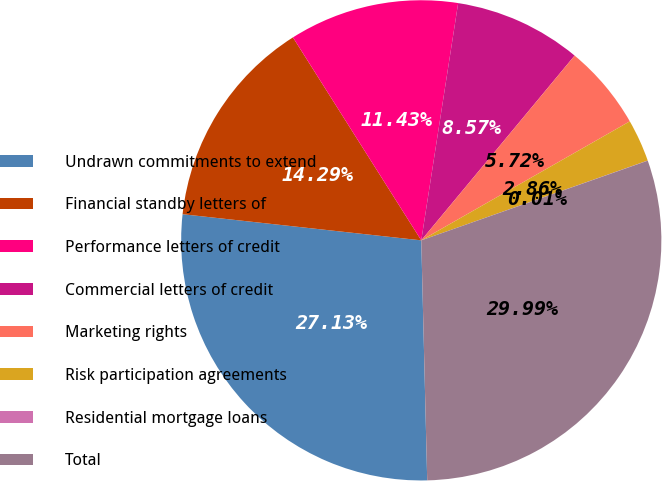<chart> <loc_0><loc_0><loc_500><loc_500><pie_chart><fcel>Undrawn commitments to extend<fcel>Financial standby letters of<fcel>Performance letters of credit<fcel>Commercial letters of credit<fcel>Marketing rights<fcel>Risk participation agreements<fcel>Residential mortgage loans<fcel>Total<nl><fcel>27.13%<fcel>14.29%<fcel>11.43%<fcel>8.57%<fcel>5.72%<fcel>2.86%<fcel>0.01%<fcel>29.99%<nl></chart> 